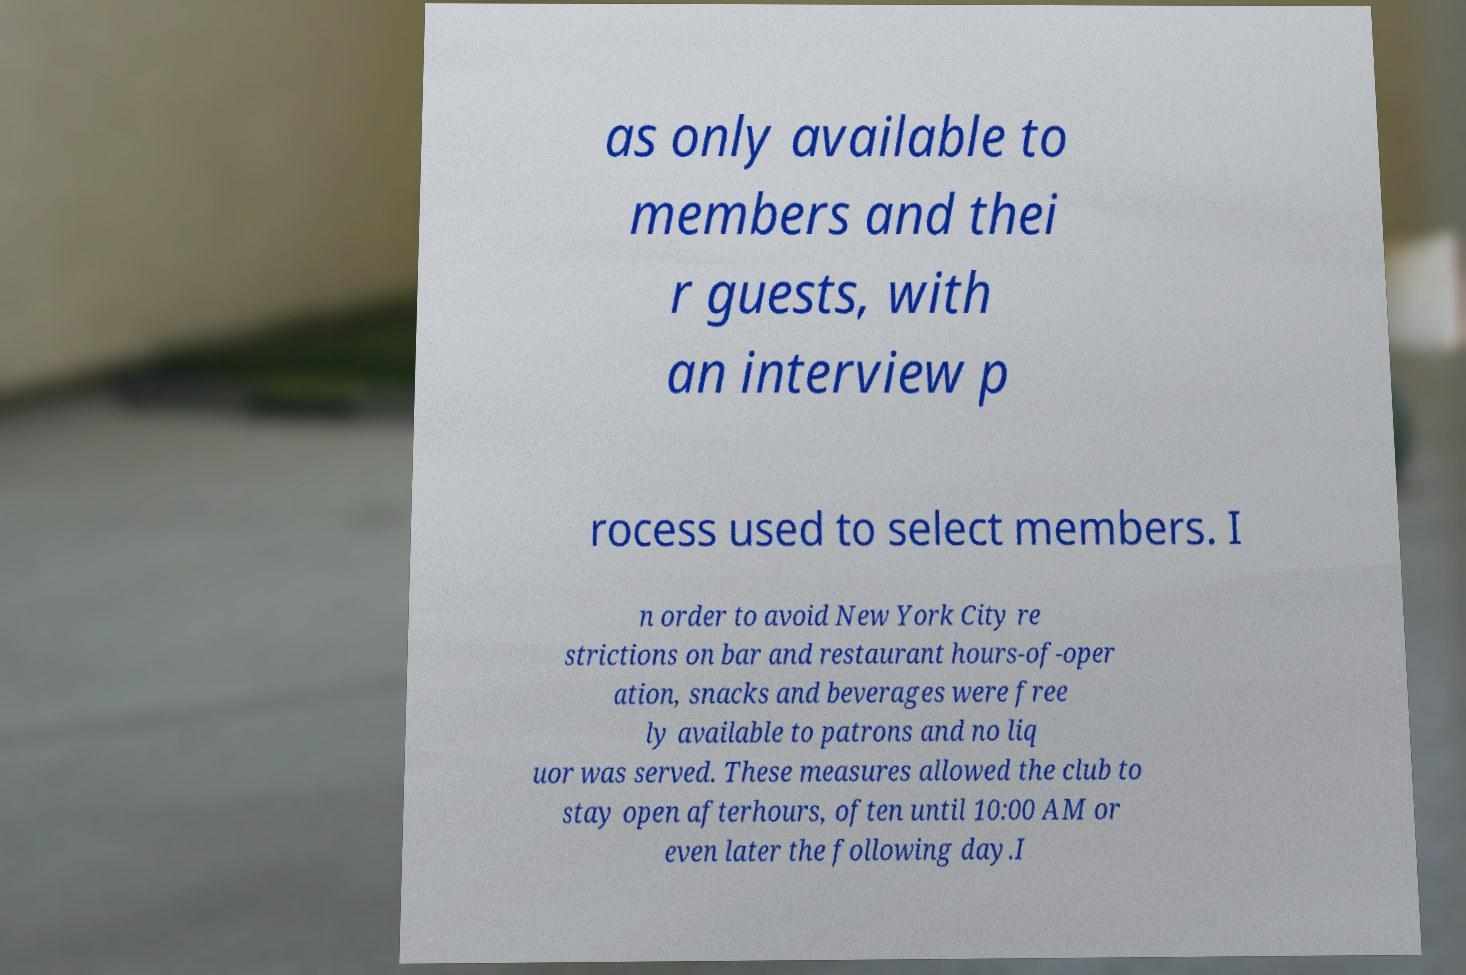Could you assist in decoding the text presented in this image and type it out clearly? as only available to members and thei r guests, with an interview p rocess used to select members. I n order to avoid New York City re strictions on bar and restaurant hours-of-oper ation, snacks and beverages were free ly available to patrons and no liq uor was served. These measures allowed the club to stay open afterhours, often until 10:00 AM or even later the following day.I 